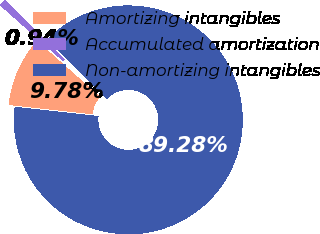Convert chart to OTSL. <chart><loc_0><loc_0><loc_500><loc_500><pie_chart><fcel>Amortizing intangibles<fcel>Accumulated amortization<fcel>Non-amortizing intangibles<nl><fcel>9.78%<fcel>0.94%<fcel>89.28%<nl></chart> 